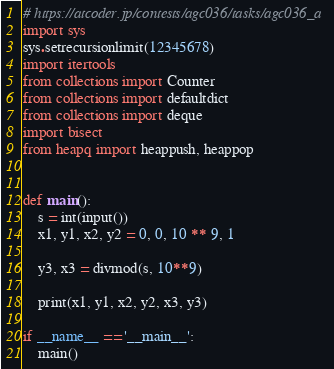Convert code to text. <code><loc_0><loc_0><loc_500><loc_500><_Python_># https://atcoder.jp/contests/agc036/tasks/agc036_a
import sys
sys.setrecursionlimit(12345678)
import itertools
from collections import Counter
from collections import defaultdict
from collections import deque
import bisect
from heapq import heappush, heappop


def main():
    s = int(input())
    x1, y1, x2, y2 = 0, 0, 10 ** 9, 1

    y3, x3 = divmod(s, 10**9)

    print(x1, y1, x2, y2, x3, y3)

if __name__ == '__main__':
    main()
</code> 